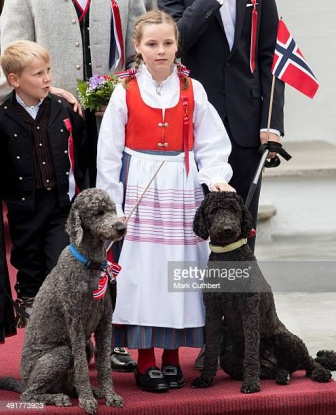Can you describe a possible short story involving the characters in this image? At the heart of Oslo, during the grand Constitution Day parade, young Ingrid stood proudly on the red carpet, holding her loyal companions, Fluffy and Shadow. As she watched the colorful floats pass by, she felt a tremendous sense of pride in her heritage. Fluffy, her gray poodle, and Shadow, her black poodle, both wore ribbons that she had carefully chosen. As the parade music swelled, Ingrid's heart swelled with joy, knowing that this day, surrounded by tradition and celebration, would be one she'd cherish forever.  What would a journalist write about this event? Yesterday, Norway's Constitution Day was celebrated with characteristic fervor and pride. Amidst the sea of colorful bunads and waving flags, a young girl named Ingrid captured the hearts of the crowd. Dressed in a traditional bunad, Ingrid stood on a red carpet with her two poodles, Fluffy and Shadow, beside her, both adorned with patriotic ribbons. The event was a vivid tapestry of cultural pride, with speeches, parades, and music filling the air. The sight of Ingrid and her loyal poodles perfectly encapsulated the blend of tradition and joy that defines this significant national holiday. 